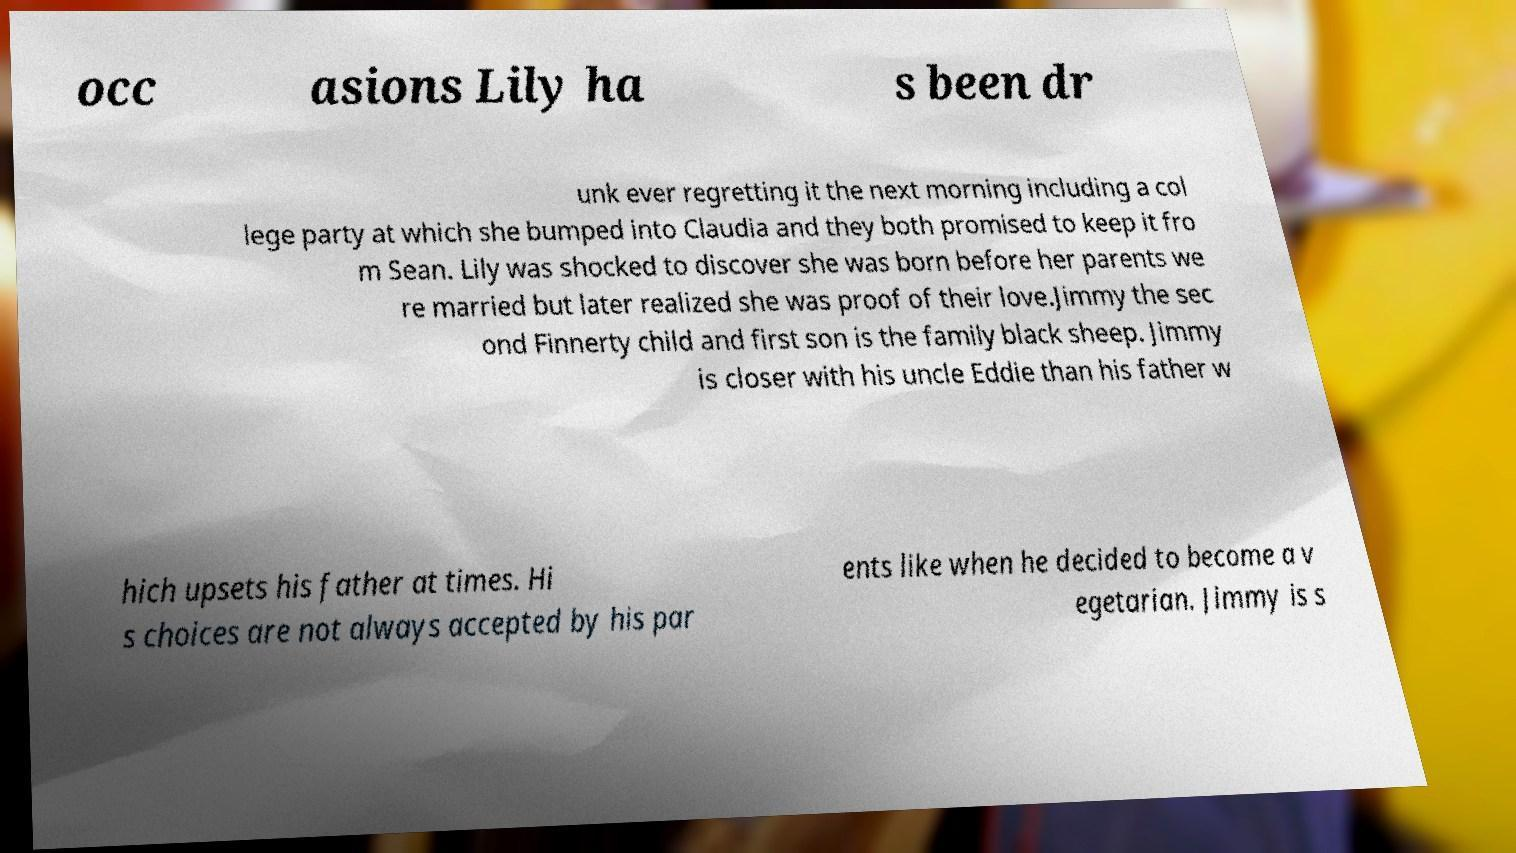There's text embedded in this image that I need extracted. Can you transcribe it verbatim? occ asions Lily ha s been dr unk ever regretting it the next morning including a col lege party at which she bumped into Claudia and they both promised to keep it fro m Sean. Lily was shocked to discover she was born before her parents we re married but later realized she was proof of their love.Jimmy the sec ond Finnerty child and first son is the family black sheep. Jimmy is closer with his uncle Eddie than his father w hich upsets his father at times. Hi s choices are not always accepted by his par ents like when he decided to become a v egetarian. Jimmy is s 